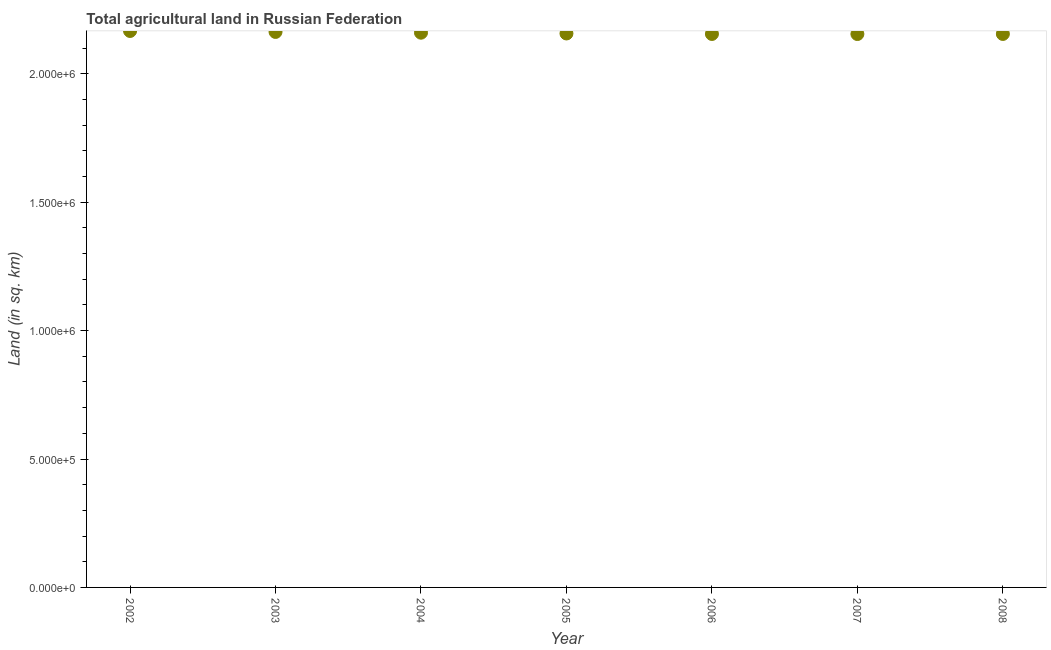What is the agricultural land in 2005?
Ensure brevity in your answer.  2.16e+06. Across all years, what is the maximum agricultural land?
Keep it short and to the point. 2.17e+06. Across all years, what is the minimum agricultural land?
Ensure brevity in your answer.  2.15e+06. In which year was the agricultural land maximum?
Keep it short and to the point. 2002. In which year was the agricultural land minimum?
Your answer should be compact. 2007. What is the sum of the agricultural land?
Your response must be concise. 1.51e+07. What is the difference between the agricultural land in 2003 and 2004?
Keep it short and to the point. 2970. What is the average agricultural land per year?
Keep it short and to the point. 2.16e+06. What is the median agricultural land?
Your response must be concise. 2.16e+06. In how many years, is the agricultural land greater than 1200000 sq. km?
Provide a short and direct response. 7. What is the ratio of the agricultural land in 2006 to that in 2007?
Your answer should be very brief. 1. Is the agricultural land in 2002 less than that in 2003?
Your answer should be very brief. No. Is the difference between the agricultural land in 2002 and 2004 greater than the difference between any two years?
Give a very brief answer. No. What is the difference between the highest and the second highest agricultural land?
Ensure brevity in your answer.  3740. Is the sum of the agricultural land in 2006 and 2008 greater than the maximum agricultural land across all years?
Give a very brief answer. Yes. What is the difference between the highest and the lowest agricultural land?
Keep it short and to the point. 1.19e+04. In how many years, is the agricultural land greater than the average agricultural land taken over all years?
Your answer should be compact. 3. How many dotlines are there?
Your response must be concise. 1. How many years are there in the graph?
Ensure brevity in your answer.  7. Are the values on the major ticks of Y-axis written in scientific E-notation?
Provide a succinct answer. Yes. Does the graph contain grids?
Keep it short and to the point. No. What is the title of the graph?
Make the answer very short. Total agricultural land in Russian Federation. What is the label or title of the Y-axis?
Your answer should be compact. Land (in sq. km). What is the Land (in sq. km) in 2002?
Give a very brief answer. 2.17e+06. What is the Land (in sq. km) in 2003?
Your answer should be compact. 2.16e+06. What is the Land (in sq. km) in 2004?
Your answer should be compact. 2.16e+06. What is the Land (in sq. km) in 2005?
Your response must be concise. 2.16e+06. What is the Land (in sq. km) in 2006?
Keep it short and to the point. 2.15e+06. What is the Land (in sq. km) in 2007?
Keep it short and to the point. 2.15e+06. What is the Land (in sq. km) in 2008?
Offer a very short reply. 2.15e+06. What is the difference between the Land (in sq. km) in 2002 and 2003?
Keep it short and to the point. 3740. What is the difference between the Land (in sq. km) in 2002 and 2004?
Offer a terse response. 6710. What is the difference between the Land (in sq. km) in 2002 and 2005?
Ensure brevity in your answer.  9710. What is the difference between the Land (in sq. km) in 2002 and 2006?
Make the answer very short. 1.16e+04. What is the difference between the Land (in sq. km) in 2002 and 2007?
Give a very brief answer. 1.19e+04. What is the difference between the Land (in sq. km) in 2002 and 2008?
Keep it short and to the point. 1.16e+04. What is the difference between the Land (in sq. km) in 2003 and 2004?
Your answer should be very brief. 2970. What is the difference between the Land (in sq. km) in 2003 and 2005?
Provide a succinct answer. 5970. What is the difference between the Land (in sq. km) in 2003 and 2006?
Your response must be concise. 7890. What is the difference between the Land (in sq. km) in 2003 and 2007?
Offer a terse response. 8140. What is the difference between the Land (in sq. km) in 2003 and 2008?
Ensure brevity in your answer.  7830. What is the difference between the Land (in sq. km) in 2004 and 2005?
Provide a short and direct response. 3000. What is the difference between the Land (in sq. km) in 2004 and 2006?
Your response must be concise. 4920. What is the difference between the Land (in sq. km) in 2004 and 2007?
Your answer should be compact. 5170. What is the difference between the Land (in sq. km) in 2004 and 2008?
Provide a succinct answer. 4860. What is the difference between the Land (in sq. km) in 2005 and 2006?
Ensure brevity in your answer.  1920. What is the difference between the Land (in sq. km) in 2005 and 2007?
Offer a very short reply. 2170. What is the difference between the Land (in sq. km) in 2005 and 2008?
Offer a very short reply. 1860. What is the difference between the Land (in sq. km) in 2006 and 2007?
Offer a very short reply. 250. What is the difference between the Land (in sq. km) in 2006 and 2008?
Your answer should be compact. -60. What is the difference between the Land (in sq. km) in 2007 and 2008?
Your answer should be very brief. -310. What is the ratio of the Land (in sq. km) in 2002 to that in 2004?
Your response must be concise. 1. What is the ratio of the Land (in sq. km) in 2002 to that in 2005?
Provide a short and direct response. 1. What is the ratio of the Land (in sq. km) in 2002 to that in 2007?
Give a very brief answer. 1.01. What is the ratio of the Land (in sq. km) in 2003 to that in 2004?
Provide a succinct answer. 1. What is the ratio of the Land (in sq. km) in 2003 to that in 2006?
Your answer should be very brief. 1. What is the ratio of the Land (in sq. km) in 2003 to that in 2007?
Offer a terse response. 1. What is the ratio of the Land (in sq. km) in 2003 to that in 2008?
Ensure brevity in your answer.  1. What is the ratio of the Land (in sq. km) in 2005 to that in 2008?
Provide a short and direct response. 1. What is the ratio of the Land (in sq. km) in 2006 to that in 2007?
Make the answer very short. 1. What is the ratio of the Land (in sq. km) in 2006 to that in 2008?
Your answer should be very brief. 1. 